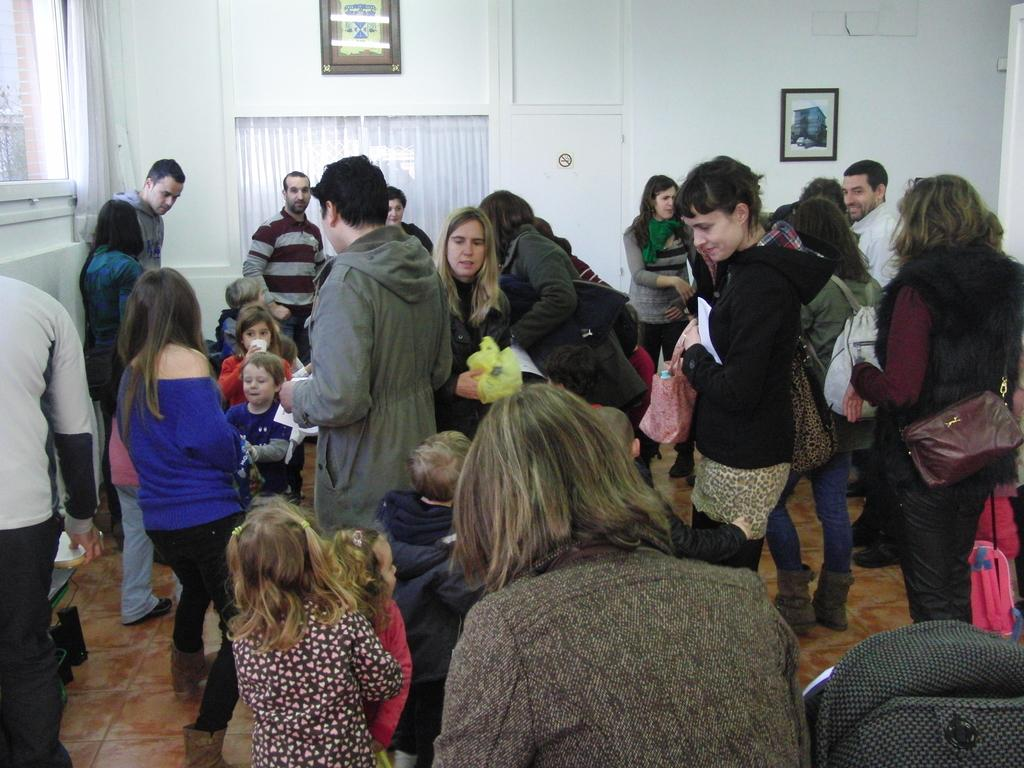What types of people are present in the room? There are men, women, and children in the room. What can be found on the wall in the room? There is a wall with curtains and photo frames on it. What type of nut is being used as a base for the mine in the room? There is no mention of a nut, base, or mine in the image, so this question cannot be answered. 